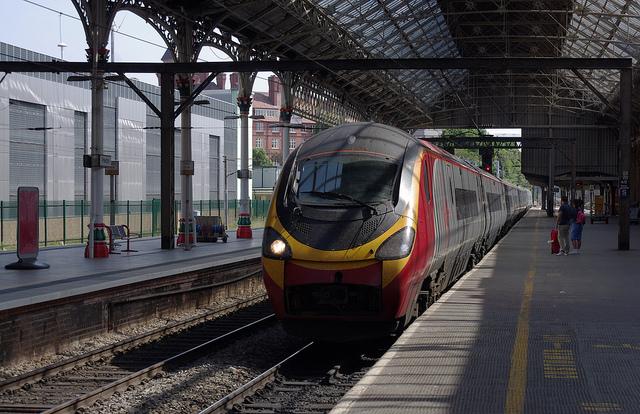How many lights are on the front of the train?
Concise answer only. 1. What kind of train in this?
Concise answer only. Passenger. What is the purpose of the yellow line on the ground?
Answer briefly. Caution. 